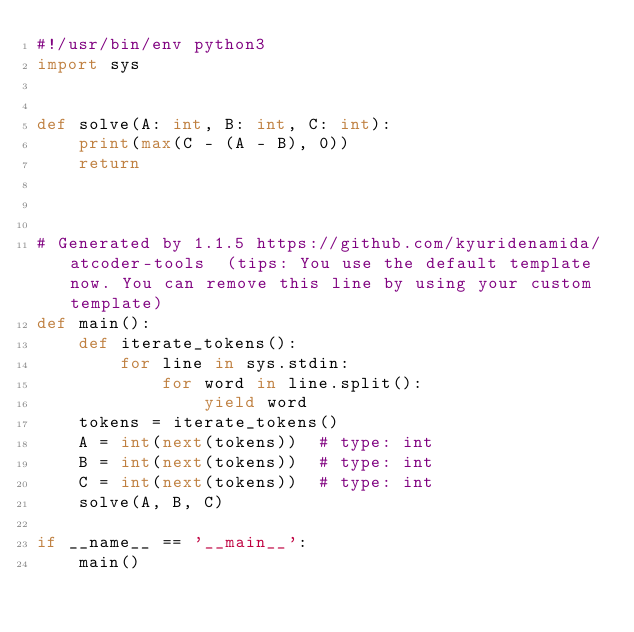Convert code to text. <code><loc_0><loc_0><loc_500><loc_500><_Python_>#!/usr/bin/env python3
import sys


def solve(A: int, B: int, C: int):
    print(max(C - (A - B), 0))
    return



# Generated by 1.1.5 https://github.com/kyuridenamida/atcoder-tools  (tips: You use the default template now. You can remove this line by using your custom template)
def main():
    def iterate_tokens():
        for line in sys.stdin:
            for word in line.split():
                yield word
    tokens = iterate_tokens()
    A = int(next(tokens))  # type: int
    B = int(next(tokens))  # type: int
    C = int(next(tokens))  # type: int
    solve(A, B, C)

if __name__ == '__main__':
    main()
</code> 